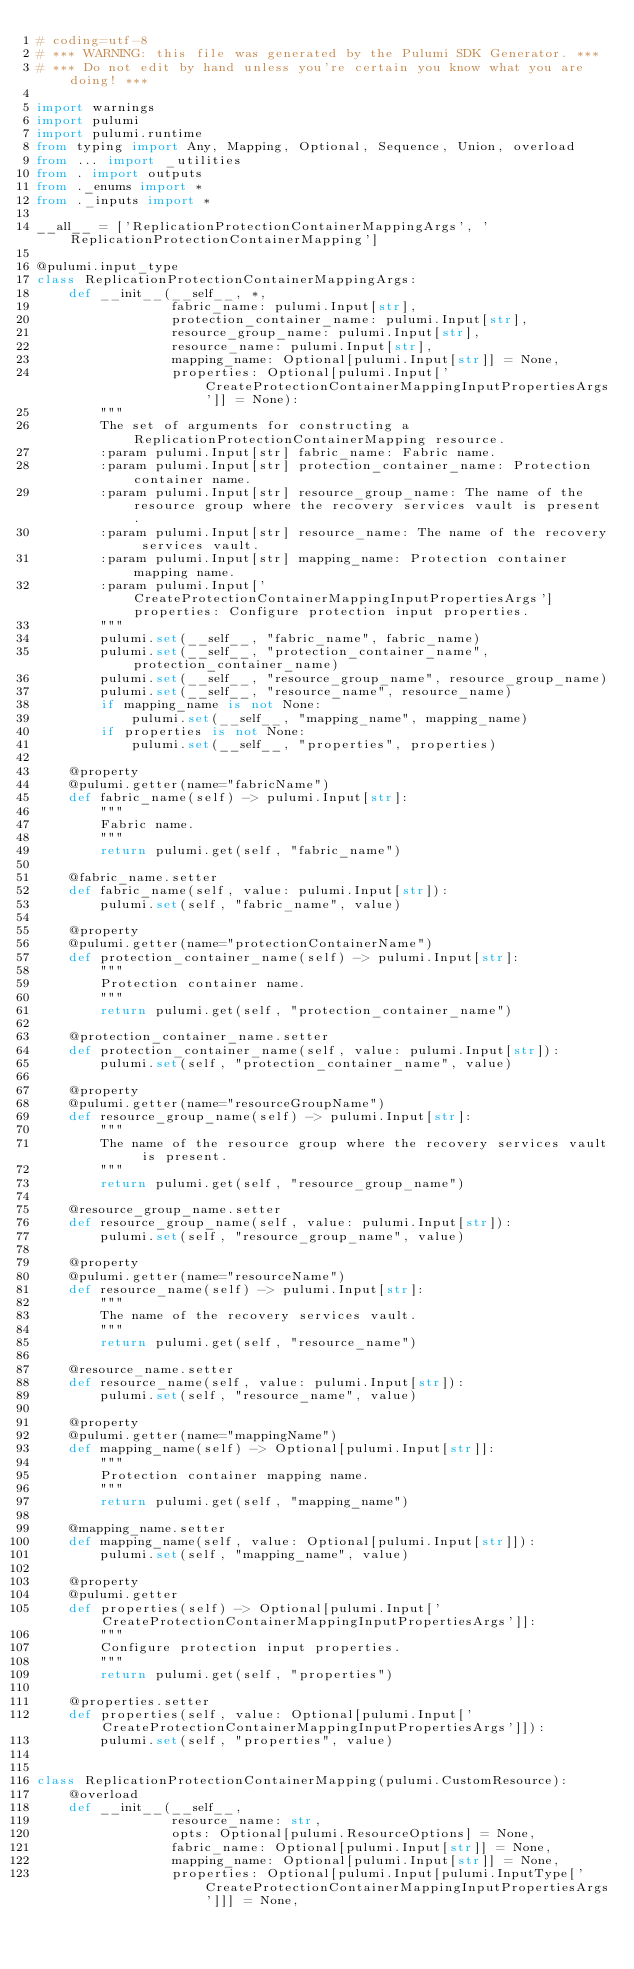<code> <loc_0><loc_0><loc_500><loc_500><_Python_># coding=utf-8
# *** WARNING: this file was generated by the Pulumi SDK Generator. ***
# *** Do not edit by hand unless you're certain you know what you are doing! ***

import warnings
import pulumi
import pulumi.runtime
from typing import Any, Mapping, Optional, Sequence, Union, overload
from ... import _utilities
from . import outputs
from ._enums import *
from ._inputs import *

__all__ = ['ReplicationProtectionContainerMappingArgs', 'ReplicationProtectionContainerMapping']

@pulumi.input_type
class ReplicationProtectionContainerMappingArgs:
    def __init__(__self__, *,
                 fabric_name: pulumi.Input[str],
                 protection_container_name: pulumi.Input[str],
                 resource_group_name: pulumi.Input[str],
                 resource_name: pulumi.Input[str],
                 mapping_name: Optional[pulumi.Input[str]] = None,
                 properties: Optional[pulumi.Input['CreateProtectionContainerMappingInputPropertiesArgs']] = None):
        """
        The set of arguments for constructing a ReplicationProtectionContainerMapping resource.
        :param pulumi.Input[str] fabric_name: Fabric name.
        :param pulumi.Input[str] protection_container_name: Protection container name.
        :param pulumi.Input[str] resource_group_name: The name of the resource group where the recovery services vault is present.
        :param pulumi.Input[str] resource_name: The name of the recovery services vault.
        :param pulumi.Input[str] mapping_name: Protection container mapping name.
        :param pulumi.Input['CreateProtectionContainerMappingInputPropertiesArgs'] properties: Configure protection input properties.
        """
        pulumi.set(__self__, "fabric_name", fabric_name)
        pulumi.set(__self__, "protection_container_name", protection_container_name)
        pulumi.set(__self__, "resource_group_name", resource_group_name)
        pulumi.set(__self__, "resource_name", resource_name)
        if mapping_name is not None:
            pulumi.set(__self__, "mapping_name", mapping_name)
        if properties is not None:
            pulumi.set(__self__, "properties", properties)

    @property
    @pulumi.getter(name="fabricName")
    def fabric_name(self) -> pulumi.Input[str]:
        """
        Fabric name.
        """
        return pulumi.get(self, "fabric_name")

    @fabric_name.setter
    def fabric_name(self, value: pulumi.Input[str]):
        pulumi.set(self, "fabric_name", value)

    @property
    @pulumi.getter(name="protectionContainerName")
    def protection_container_name(self) -> pulumi.Input[str]:
        """
        Protection container name.
        """
        return pulumi.get(self, "protection_container_name")

    @protection_container_name.setter
    def protection_container_name(self, value: pulumi.Input[str]):
        pulumi.set(self, "protection_container_name", value)

    @property
    @pulumi.getter(name="resourceGroupName")
    def resource_group_name(self) -> pulumi.Input[str]:
        """
        The name of the resource group where the recovery services vault is present.
        """
        return pulumi.get(self, "resource_group_name")

    @resource_group_name.setter
    def resource_group_name(self, value: pulumi.Input[str]):
        pulumi.set(self, "resource_group_name", value)

    @property
    @pulumi.getter(name="resourceName")
    def resource_name(self) -> pulumi.Input[str]:
        """
        The name of the recovery services vault.
        """
        return pulumi.get(self, "resource_name")

    @resource_name.setter
    def resource_name(self, value: pulumi.Input[str]):
        pulumi.set(self, "resource_name", value)

    @property
    @pulumi.getter(name="mappingName")
    def mapping_name(self) -> Optional[pulumi.Input[str]]:
        """
        Protection container mapping name.
        """
        return pulumi.get(self, "mapping_name")

    @mapping_name.setter
    def mapping_name(self, value: Optional[pulumi.Input[str]]):
        pulumi.set(self, "mapping_name", value)

    @property
    @pulumi.getter
    def properties(self) -> Optional[pulumi.Input['CreateProtectionContainerMappingInputPropertiesArgs']]:
        """
        Configure protection input properties.
        """
        return pulumi.get(self, "properties")

    @properties.setter
    def properties(self, value: Optional[pulumi.Input['CreateProtectionContainerMappingInputPropertiesArgs']]):
        pulumi.set(self, "properties", value)


class ReplicationProtectionContainerMapping(pulumi.CustomResource):
    @overload
    def __init__(__self__,
                 resource_name: str,
                 opts: Optional[pulumi.ResourceOptions] = None,
                 fabric_name: Optional[pulumi.Input[str]] = None,
                 mapping_name: Optional[pulumi.Input[str]] = None,
                 properties: Optional[pulumi.Input[pulumi.InputType['CreateProtectionContainerMappingInputPropertiesArgs']]] = None,</code> 